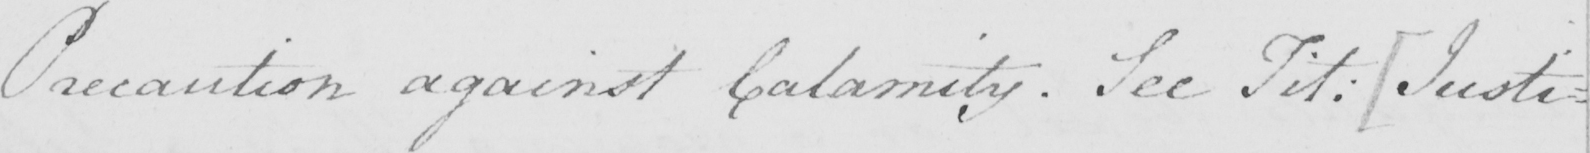What is written in this line of handwriting? Precaution against Calamity . See Tit :   [ Justi= 